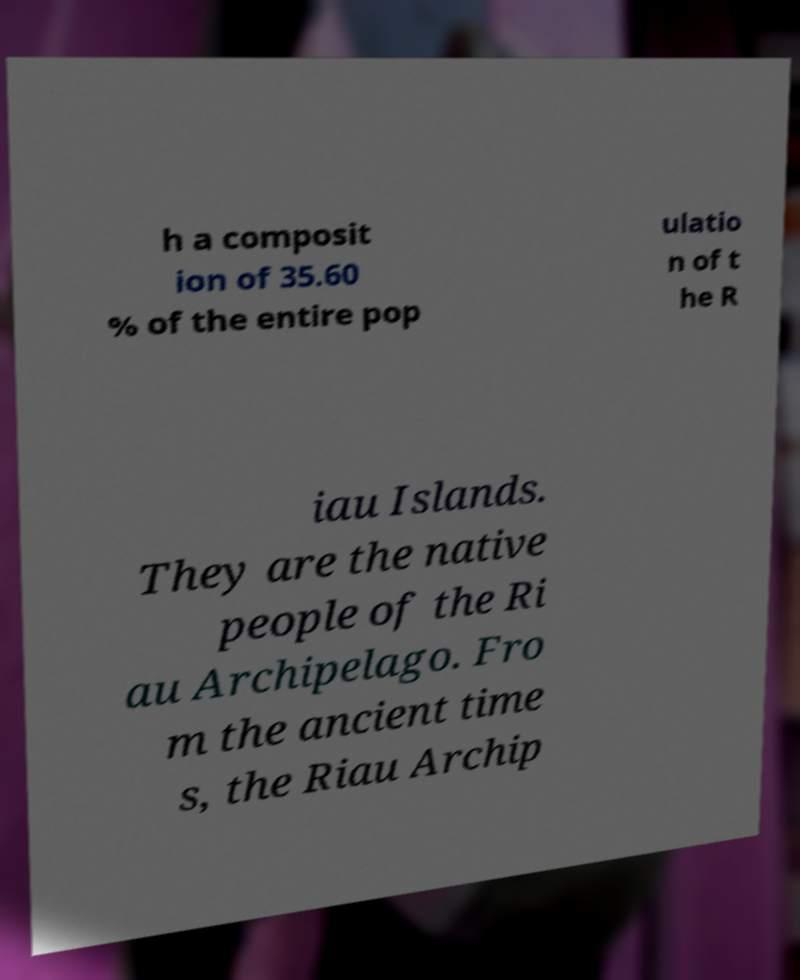I need the written content from this picture converted into text. Can you do that? h a composit ion of 35.60 % of the entire pop ulatio n of t he R iau Islands. They are the native people of the Ri au Archipelago. Fro m the ancient time s, the Riau Archip 